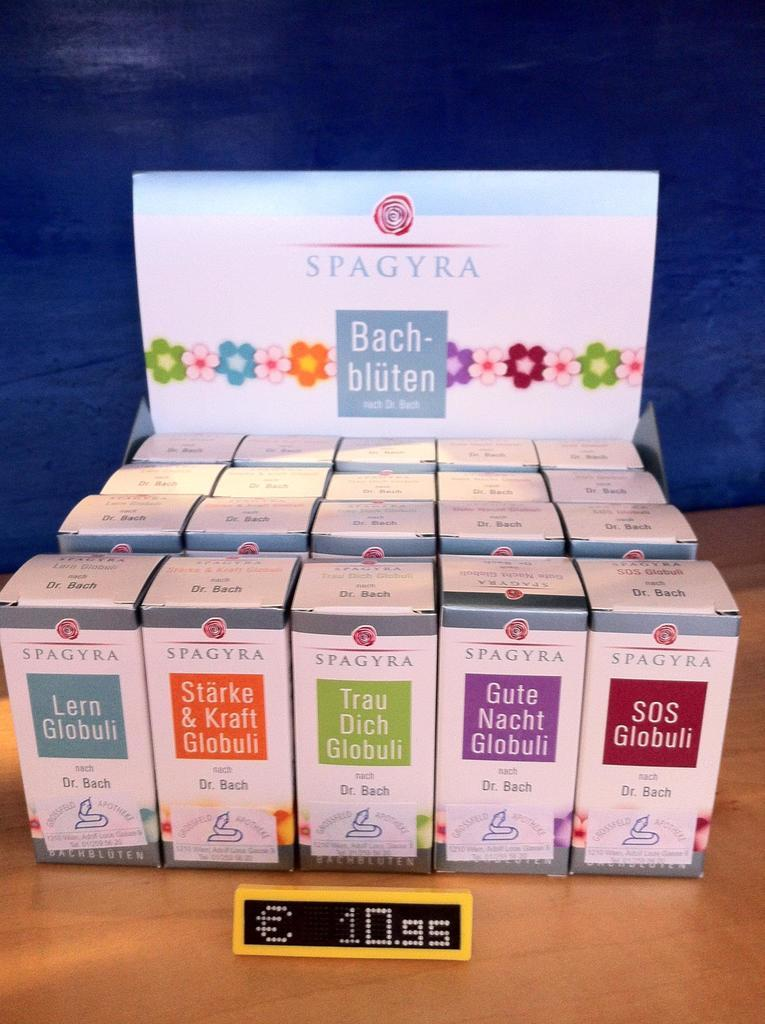<image>
Write a terse but informative summary of the picture. A display of various Spagyra products sitting on a table. 